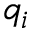Convert formula to latex. <formula><loc_0><loc_0><loc_500><loc_500>q _ { i }</formula> 